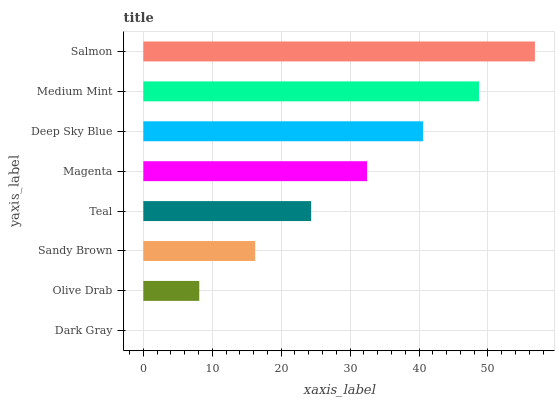Is Dark Gray the minimum?
Answer yes or no. Yes. Is Salmon the maximum?
Answer yes or no. Yes. Is Olive Drab the minimum?
Answer yes or no. No. Is Olive Drab the maximum?
Answer yes or no. No. Is Olive Drab greater than Dark Gray?
Answer yes or no. Yes. Is Dark Gray less than Olive Drab?
Answer yes or no. Yes. Is Dark Gray greater than Olive Drab?
Answer yes or no. No. Is Olive Drab less than Dark Gray?
Answer yes or no. No. Is Magenta the high median?
Answer yes or no. Yes. Is Teal the low median?
Answer yes or no. Yes. Is Deep Sky Blue the high median?
Answer yes or no. No. Is Dark Gray the low median?
Answer yes or no. No. 